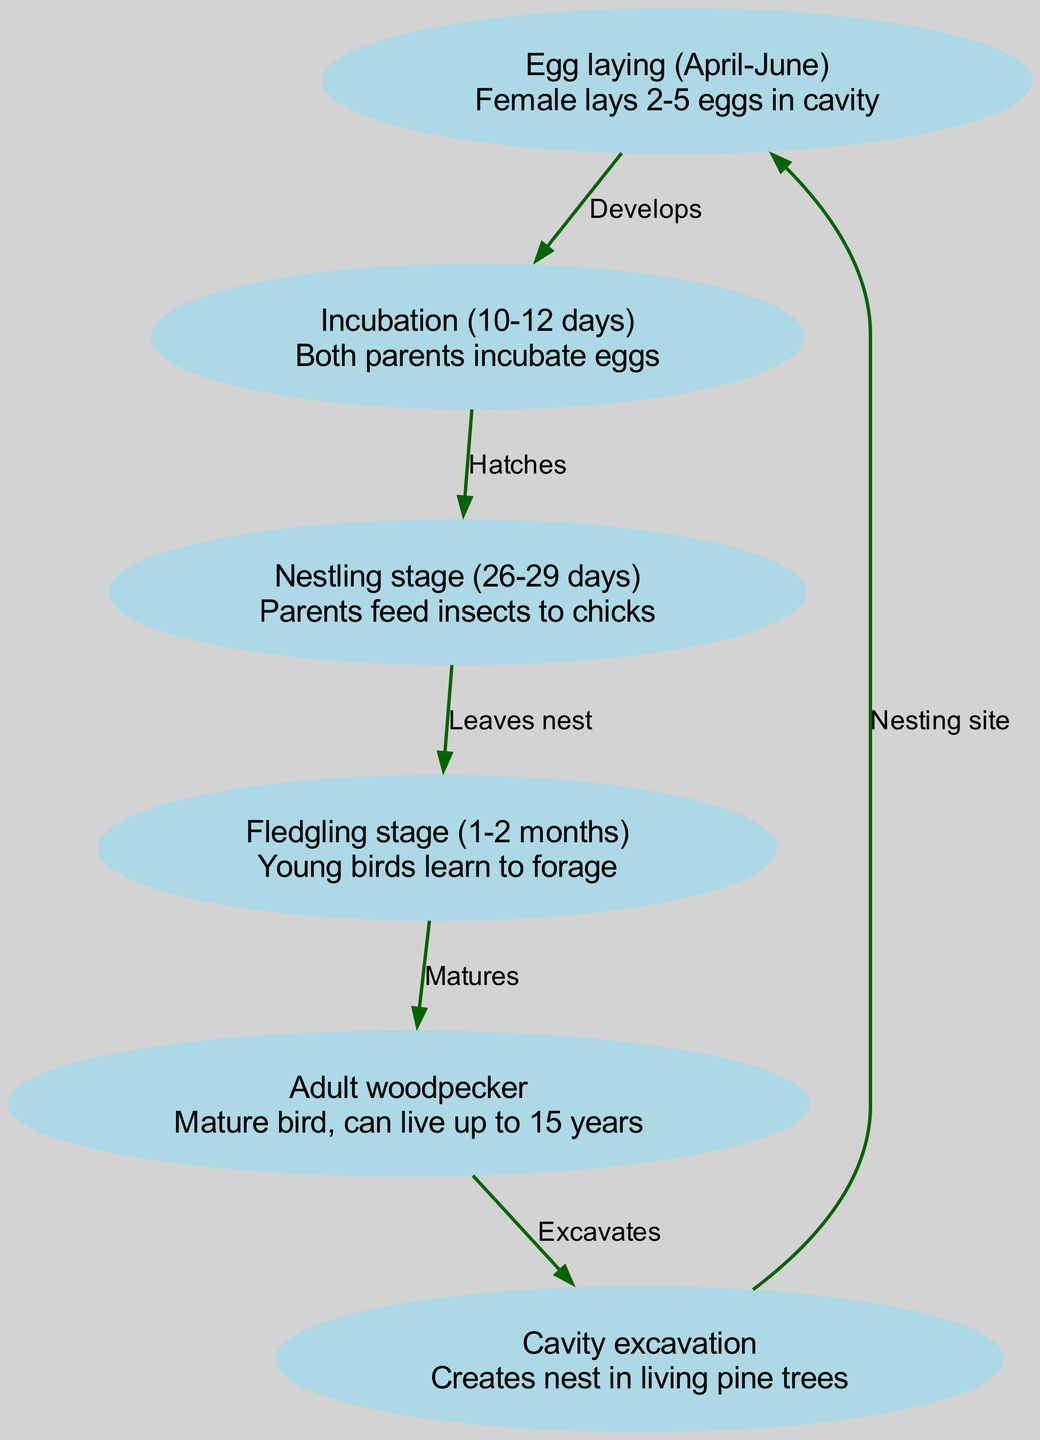What stage follows egg laying? The diagram indicates that after the egg laying stage, incubation occurs, as the edge shows the progression from the 'egg' node to the 'incubation' node.
Answer: Incubation How many eggs does the female lay? According to the description in the 'egg' node, the female red-cockaded woodpecker lays 2-5 eggs.
Answer: 2-5 What is the duration of the nestling stage? The 'nestling stage' node states that this stage lasts for 26-29 days, providing the duration of the nestling phase.
Answer: 26-29 days What activity is associated with adult woodpeckers? The diagram shows that adult woodpeckers excavate cavities in living pine trees, as indicated by the edge connecting the 'adult woodpecker' node to the 'cavity excavation' node.
Answer: Excavates What is the last stage in the life cycle? The final stage indicated in the diagram is the adult woodpecker stage, which follows the fledgling stage, based on the edges connecting these nodes.
Answer: Adult woodpecker What happens after the incubation phase? The edge from the 'incubation' node points to the 'nestling' node, indicating that after incubation, the eggs hatch to enter the nestling phase.
Answer: Hatches How long does the incubation last? The 'incubation' node states that this stage lasts 10-12 days, which provides the duration of the incubation phase.
Answer: 10-12 days What begins the life cycle? The life cycle begins with egg laying, as depicted in the diagram with the 'egg' node being the first stage in this cycle.
Answer: Egg laying How does a fledgling become an adult woodpecker? The arrow from the 'fledgling' node to the 'adult' node indicates that fledglings mature to become adult woodpeckers, showing the transition between these stages.
Answer: Matures 